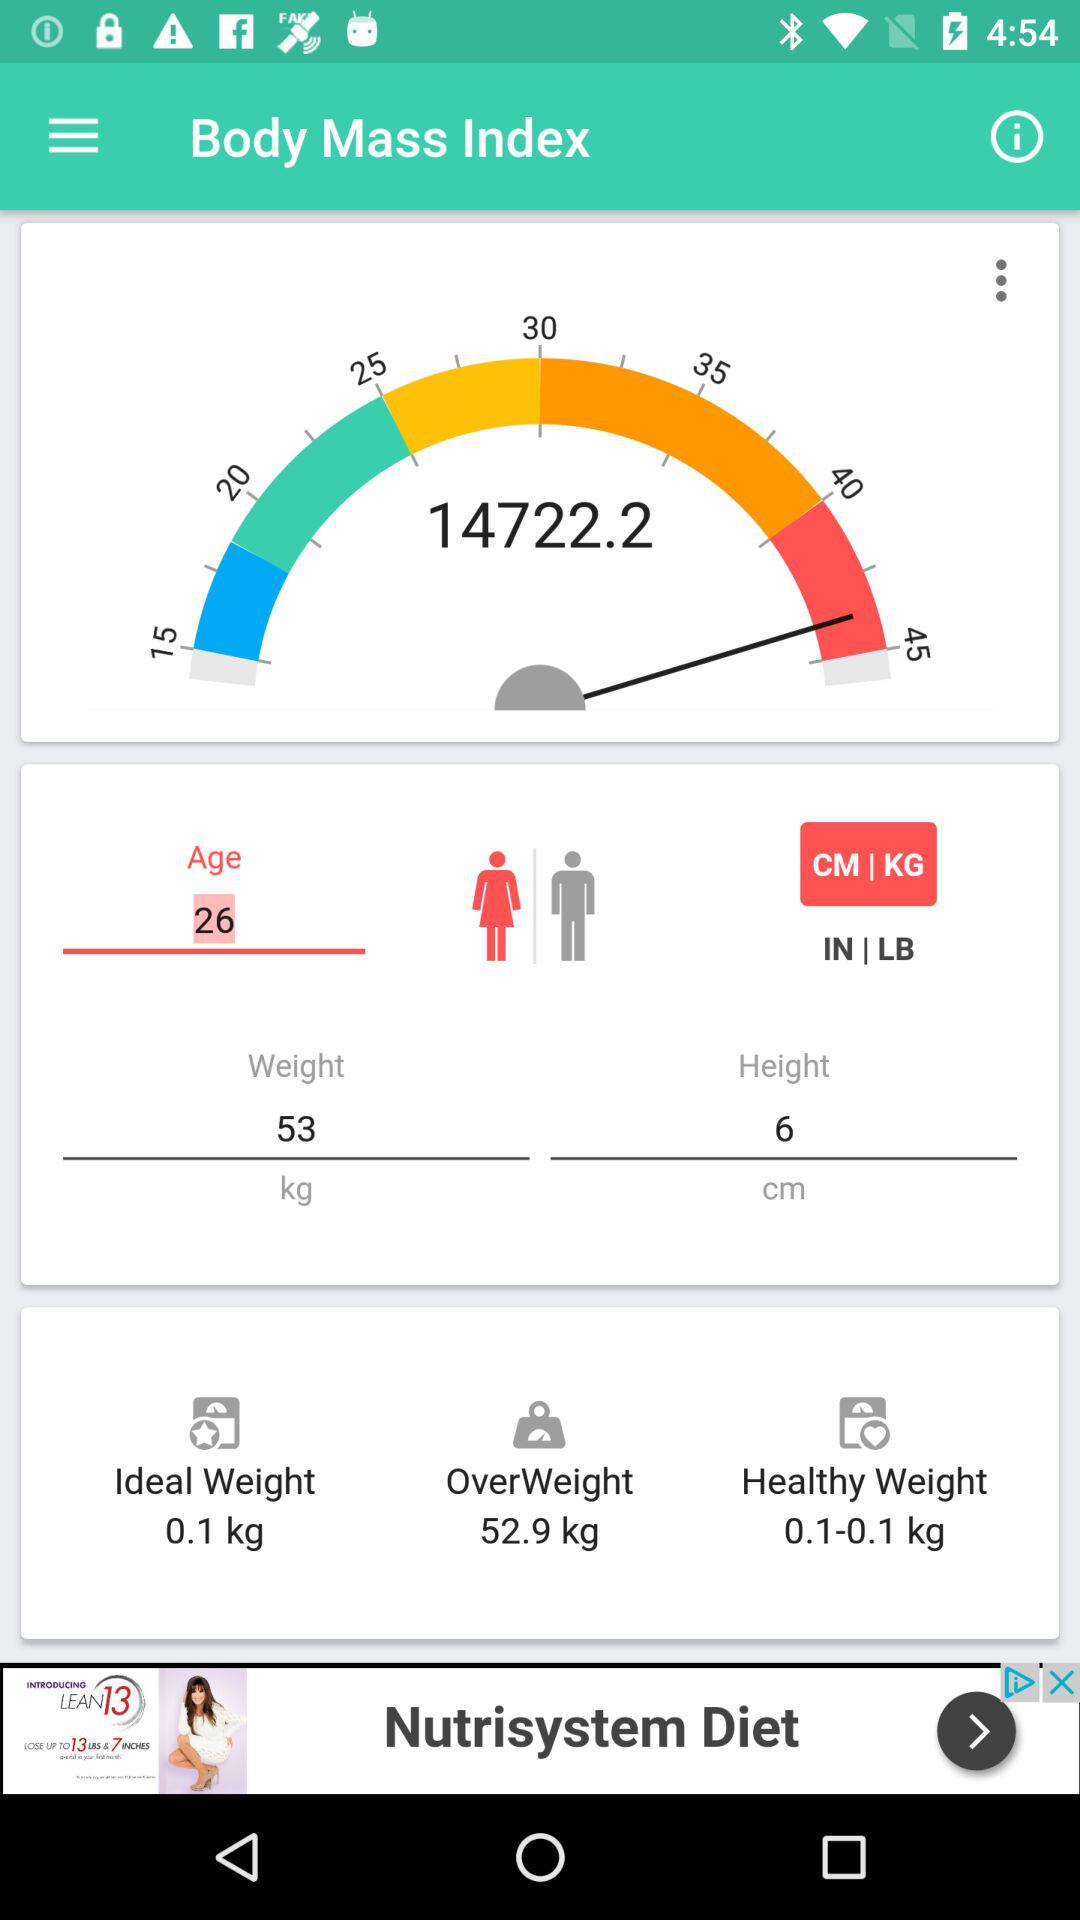What weight is given in "OverWeight"? The given weight in "OverWeight" is 52.9 kg. 